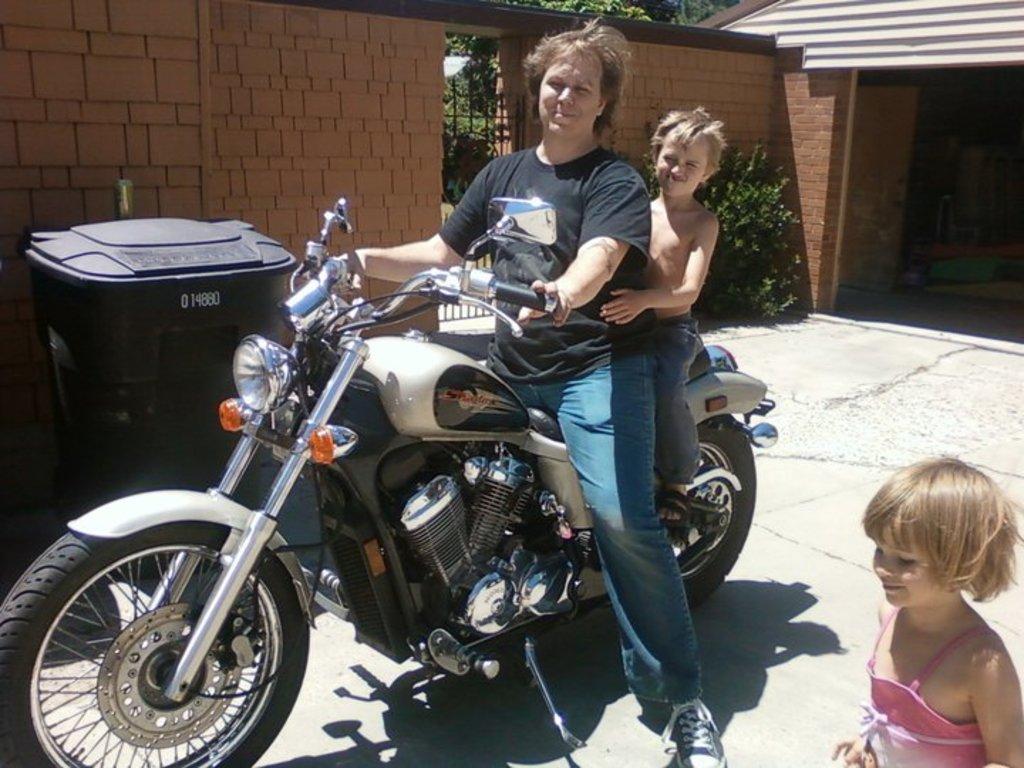How would you summarize this image in a sentence or two? In this image a man and a child sitting on a bike beside them the other child is standing, at the back ground there is a wall, a tank and a plant. 